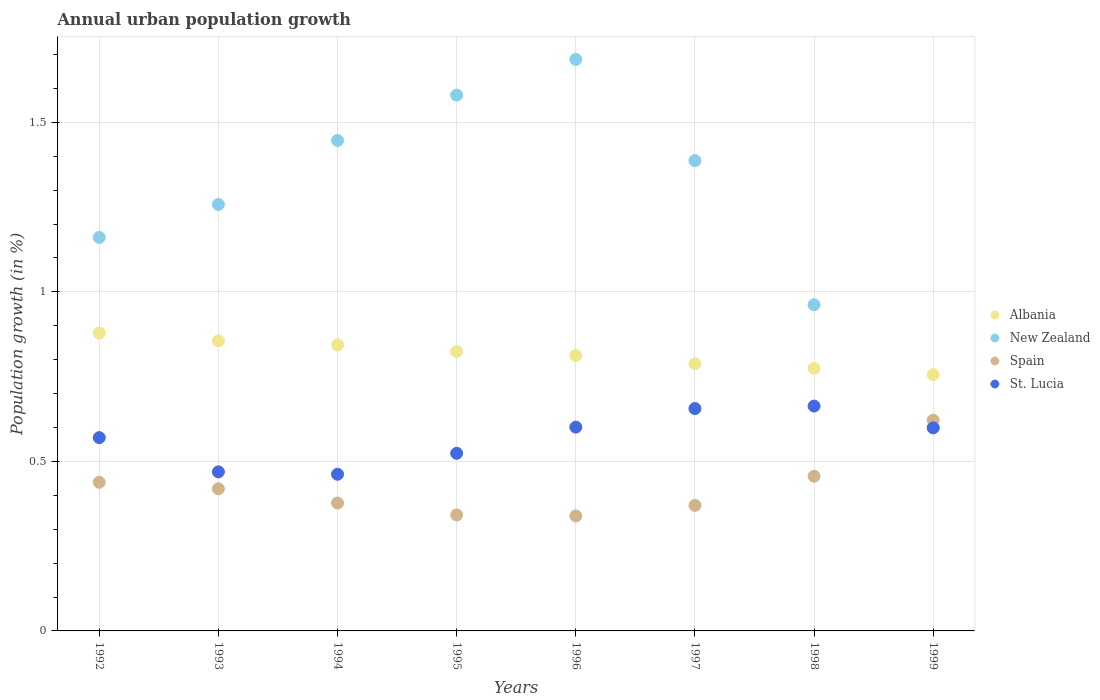How many different coloured dotlines are there?
Your response must be concise. 4. Is the number of dotlines equal to the number of legend labels?
Your response must be concise. Yes. What is the percentage of urban population growth in New Zealand in 1994?
Ensure brevity in your answer.  1.45. Across all years, what is the maximum percentage of urban population growth in St. Lucia?
Your answer should be very brief. 0.66. Across all years, what is the minimum percentage of urban population growth in St. Lucia?
Keep it short and to the point. 0.46. In which year was the percentage of urban population growth in Spain minimum?
Offer a terse response. 1996. What is the total percentage of urban population growth in New Zealand in the graph?
Keep it short and to the point. 10.08. What is the difference between the percentage of urban population growth in St. Lucia in 1993 and that in 1996?
Make the answer very short. -0.13. What is the difference between the percentage of urban population growth in St. Lucia in 1992 and the percentage of urban population growth in New Zealand in 1994?
Your answer should be compact. -0.88. What is the average percentage of urban population growth in New Zealand per year?
Offer a very short reply. 1.26. In the year 1994, what is the difference between the percentage of urban population growth in Spain and percentage of urban population growth in New Zealand?
Provide a succinct answer. -1.07. In how many years, is the percentage of urban population growth in New Zealand greater than 0.2 %?
Make the answer very short. 8. What is the ratio of the percentage of urban population growth in St. Lucia in 1994 to that in 1995?
Offer a terse response. 0.88. Is the percentage of urban population growth in Albania in 1992 less than that in 1999?
Your answer should be very brief. No. Is the difference between the percentage of urban population growth in Spain in 1993 and 1998 greater than the difference between the percentage of urban population growth in New Zealand in 1993 and 1998?
Your response must be concise. No. What is the difference between the highest and the second highest percentage of urban population growth in Spain?
Offer a very short reply. 0.17. What is the difference between the highest and the lowest percentage of urban population growth in Albania?
Ensure brevity in your answer.  0.12. In how many years, is the percentage of urban population growth in Albania greater than the average percentage of urban population growth in Albania taken over all years?
Keep it short and to the point. 4. Is the sum of the percentage of urban population growth in New Zealand in 1997 and 1999 greater than the maximum percentage of urban population growth in Albania across all years?
Make the answer very short. Yes. Is it the case that in every year, the sum of the percentage of urban population growth in St. Lucia and percentage of urban population growth in Spain  is greater than the sum of percentage of urban population growth in Albania and percentage of urban population growth in New Zealand?
Make the answer very short. No. Is it the case that in every year, the sum of the percentage of urban population growth in Albania and percentage of urban population growth in Spain  is greater than the percentage of urban population growth in St. Lucia?
Ensure brevity in your answer.  Yes. Is the percentage of urban population growth in New Zealand strictly greater than the percentage of urban population growth in Spain over the years?
Provide a succinct answer. No. Is the percentage of urban population growth in Albania strictly less than the percentage of urban population growth in Spain over the years?
Give a very brief answer. No. How many years are there in the graph?
Your response must be concise. 8. Are the values on the major ticks of Y-axis written in scientific E-notation?
Provide a succinct answer. No. Does the graph contain grids?
Your answer should be compact. Yes. Where does the legend appear in the graph?
Your response must be concise. Center right. How are the legend labels stacked?
Offer a terse response. Vertical. What is the title of the graph?
Provide a succinct answer. Annual urban population growth. What is the label or title of the X-axis?
Your answer should be compact. Years. What is the label or title of the Y-axis?
Keep it short and to the point. Population growth (in %). What is the Population growth (in %) in Albania in 1992?
Offer a terse response. 0.88. What is the Population growth (in %) of New Zealand in 1992?
Your answer should be very brief. 1.16. What is the Population growth (in %) in Spain in 1992?
Provide a short and direct response. 0.44. What is the Population growth (in %) of St. Lucia in 1992?
Offer a terse response. 0.57. What is the Population growth (in %) of Albania in 1993?
Provide a succinct answer. 0.86. What is the Population growth (in %) in New Zealand in 1993?
Ensure brevity in your answer.  1.26. What is the Population growth (in %) of Spain in 1993?
Ensure brevity in your answer.  0.42. What is the Population growth (in %) of St. Lucia in 1993?
Your response must be concise. 0.47. What is the Population growth (in %) in Albania in 1994?
Provide a succinct answer. 0.84. What is the Population growth (in %) in New Zealand in 1994?
Give a very brief answer. 1.45. What is the Population growth (in %) of Spain in 1994?
Your answer should be compact. 0.38. What is the Population growth (in %) in St. Lucia in 1994?
Give a very brief answer. 0.46. What is the Population growth (in %) of Albania in 1995?
Provide a succinct answer. 0.82. What is the Population growth (in %) of New Zealand in 1995?
Your answer should be very brief. 1.58. What is the Population growth (in %) in Spain in 1995?
Give a very brief answer. 0.34. What is the Population growth (in %) in St. Lucia in 1995?
Your answer should be very brief. 0.52. What is the Population growth (in %) in Albania in 1996?
Give a very brief answer. 0.81. What is the Population growth (in %) of New Zealand in 1996?
Your answer should be compact. 1.69. What is the Population growth (in %) of Spain in 1996?
Offer a very short reply. 0.34. What is the Population growth (in %) in St. Lucia in 1996?
Your response must be concise. 0.6. What is the Population growth (in %) in Albania in 1997?
Your response must be concise. 0.79. What is the Population growth (in %) in New Zealand in 1997?
Provide a succinct answer. 1.39. What is the Population growth (in %) of Spain in 1997?
Offer a very short reply. 0.37. What is the Population growth (in %) of St. Lucia in 1997?
Provide a short and direct response. 0.66. What is the Population growth (in %) of Albania in 1998?
Provide a succinct answer. 0.77. What is the Population growth (in %) of New Zealand in 1998?
Your answer should be compact. 0.96. What is the Population growth (in %) in Spain in 1998?
Keep it short and to the point. 0.46. What is the Population growth (in %) in St. Lucia in 1998?
Your answer should be very brief. 0.66. What is the Population growth (in %) in Albania in 1999?
Keep it short and to the point. 0.76. What is the Population growth (in %) in New Zealand in 1999?
Your answer should be very brief. 0.6. What is the Population growth (in %) in Spain in 1999?
Your answer should be compact. 0.62. What is the Population growth (in %) in St. Lucia in 1999?
Provide a short and direct response. 0.6. Across all years, what is the maximum Population growth (in %) in Albania?
Provide a short and direct response. 0.88. Across all years, what is the maximum Population growth (in %) of New Zealand?
Your answer should be very brief. 1.69. Across all years, what is the maximum Population growth (in %) of Spain?
Provide a short and direct response. 0.62. Across all years, what is the maximum Population growth (in %) in St. Lucia?
Make the answer very short. 0.66. Across all years, what is the minimum Population growth (in %) of Albania?
Give a very brief answer. 0.76. Across all years, what is the minimum Population growth (in %) in New Zealand?
Provide a succinct answer. 0.6. Across all years, what is the minimum Population growth (in %) of Spain?
Make the answer very short. 0.34. Across all years, what is the minimum Population growth (in %) of St. Lucia?
Your answer should be compact. 0.46. What is the total Population growth (in %) of Albania in the graph?
Provide a short and direct response. 6.53. What is the total Population growth (in %) in New Zealand in the graph?
Provide a short and direct response. 10.08. What is the total Population growth (in %) of Spain in the graph?
Offer a terse response. 3.36. What is the total Population growth (in %) in St. Lucia in the graph?
Keep it short and to the point. 4.54. What is the difference between the Population growth (in %) of Albania in 1992 and that in 1993?
Make the answer very short. 0.02. What is the difference between the Population growth (in %) in New Zealand in 1992 and that in 1993?
Provide a short and direct response. -0.1. What is the difference between the Population growth (in %) in Spain in 1992 and that in 1993?
Ensure brevity in your answer.  0.02. What is the difference between the Population growth (in %) of St. Lucia in 1992 and that in 1993?
Give a very brief answer. 0.1. What is the difference between the Population growth (in %) in Albania in 1992 and that in 1994?
Your answer should be compact. 0.03. What is the difference between the Population growth (in %) of New Zealand in 1992 and that in 1994?
Provide a short and direct response. -0.29. What is the difference between the Population growth (in %) in Spain in 1992 and that in 1994?
Your answer should be very brief. 0.06. What is the difference between the Population growth (in %) of St. Lucia in 1992 and that in 1994?
Your response must be concise. 0.11. What is the difference between the Population growth (in %) in Albania in 1992 and that in 1995?
Keep it short and to the point. 0.05. What is the difference between the Population growth (in %) in New Zealand in 1992 and that in 1995?
Offer a very short reply. -0.42. What is the difference between the Population growth (in %) of Spain in 1992 and that in 1995?
Give a very brief answer. 0.1. What is the difference between the Population growth (in %) of St. Lucia in 1992 and that in 1995?
Make the answer very short. 0.05. What is the difference between the Population growth (in %) in Albania in 1992 and that in 1996?
Give a very brief answer. 0.07. What is the difference between the Population growth (in %) of New Zealand in 1992 and that in 1996?
Make the answer very short. -0.53. What is the difference between the Population growth (in %) in Spain in 1992 and that in 1996?
Offer a terse response. 0.1. What is the difference between the Population growth (in %) of St. Lucia in 1992 and that in 1996?
Your answer should be compact. -0.03. What is the difference between the Population growth (in %) of Albania in 1992 and that in 1997?
Your response must be concise. 0.09. What is the difference between the Population growth (in %) in New Zealand in 1992 and that in 1997?
Make the answer very short. -0.23. What is the difference between the Population growth (in %) of Spain in 1992 and that in 1997?
Your answer should be compact. 0.07. What is the difference between the Population growth (in %) of St. Lucia in 1992 and that in 1997?
Provide a succinct answer. -0.09. What is the difference between the Population growth (in %) in Albania in 1992 and that in 1998?
Keep it short and to the point. 0.1. What is the difference between the Population growth (in %) of New Zealand in 1992 and that in 1998?
Make the answer very short. 0.2. What is the difference between the Population growth (in %) of Spain in 1992 and that in 1998?
Ensure brevity in your answer.  -0.02. What is the difference between the Population growth (in %) of St. Lucia in 1992 and that in 1998?
Your answer should be compact. -0.09. What is the difference between the Population growth (in %) in Albania in 1992 and that in 1999?
Give a very brief answer. 0.12. What is the difference between the Population growth (in %) in New Zealand in 1992 and that in 1999?
Your answer should be compact. 0.56. What is the difference between the Population growth (in %) in Spain in 1992 and that in 1999?
Provide a succinct answer. -0.18. What is the difference between the Population growth (in %) of St. Lucia in 1992 and that in 1999?
Provide a succinct answer. -0.03. What is the difference between the Population growth (in %) in Albania in 1993 and that in 1994?
Your answer should be very brief. 0.01. What is the difference between the Population growth (in %) in New Zealand in 1993 and that in 1994?
Offer a terse response. -0.19. What is the difference between the Population growth (in %) in Spain in 1993 and that in 1994?
Your answer should be very brief. 0.04. What is the difference between the Population growth (in %) in St. Lucia in 1993 and that in 1994?
Ensure brevity in your answer.  0.01. What is the difference between the Population growth (in %) of Albania in 1993 and that in 1995?
Give a very brief answer. 0.03. What is the difference between the Population growth (in %) of New Zealand in 1993 and that in 1995?
Your response must be concise. -0.32. What is the difference between the Population growth (in %) of Spain in 1993 and that in 1995?
Your answer should be compact. 0.08. What is the difference between the Population growth (in %) in St. Lucia in 1993 and that in 1995?
Your answer should be compact. -0.05. What is the difference between the Population growth (in %) in Albania in 1993 and that in 1996?
Offer a very short reply. 0.04. What is the difference between the Population growth (in %) in New Zealand in 1993 and that in 1996?
Give a very brief answer. -0.43. What is the difference between the Population growth (in %) of Spain in 1993 and that in 1996?
Keep it short and to the point. 0.08. What is the difference between the Population growth (in %) in St. Lucia in 1993 and that in 1996?
Provide a short and direct response. -0.13. What is the difference between the Population growth (in %) of Albania in 1993 and that in 1997?
Your response must be concise. 0.07. What is the difference between the Population growth (in %) in New Zealand in 1993 and that in 1997?
Provide a short and direct response. -0.13. What is the difference between the Population growth (in %) of Spain in 1993 and that in 1997?
Keep it short and to the point. 0.05. What is the difference between the Population growth (in %) of St. Lucia in 1993 and that in 1997?
Give a very brief answer. -0.19. What is the difference between the Population growth (in %) of Albania in 1993 and that in 1998?
Offer a very short reply. 0.08. What is the difference between the Population growth (in %) of New Zealand in 1993 and that in 1998?
Ensure brevity in your answer.  0.3. What is the difference between the Population growth (in %) of Spain in 1993 and that in 1998?
Make the answer very short. -0.04. What is the difference between the Population growth (in %) in St. Lucia in 1993 and that in 1998?
Your answer should be compact. -0.19. What is the difference between the Population growth (in %) of Albania in 1993 and that in 1999?
Offer a terse response. 0.1. What is the difference between the Population growth (in %) of New Zealand in 1993 and that in 1999?
Make the answer very short. 0.66. What is the difference between the Population growth (in %) in Spain in 1993 and that in 1999?
Keep it short and to the point. -0.2. What is the difference between the Population growth (in %) of St. Lucia in 1993 and that in 1999?
Keep it short and to the point. -0.13. What is the difference between the Population growth (in %) in Albania in 1994 and that in 1995?
Your answer should be compact. 0.02. What is the difference between the Population growth (in %) of New Zealand in 1994 and that in 1995?
Your response must be concise. -0.13. What is the difference between the Population growth (in %) of Spain in 1994 and that in 1995?
Offer a very short reply. 0.04. What is the difference between the Population growth (in %) of St. Lucia in 1994 and that in 1995?
Your answer should be compact. -0.06. What is the difference between the Population growth (in %) in Albania in 1994 and that in 1996?
Offer a very short reply. 0.03. What is the difference between the Population growth (in %) in New Zealand in 1994 and that in 1996?
Offer a very short reply. -0.24. What is the difference between the Population growth (in %) in Spain in 1994 and that in 1996?
Offer a terse response. 0.04. What is the difference between the Population growth (in %) in St. Lucia in 1994 and that in 1996?
Provide a succinct answer. -0.14. What is the difference between the Population growth (in %) in Albania in 1994 and that in 1997?
Provide a short and direct response. 0.06. What is the difference between the Population growth (in %) in New Zealand in 1994 and that in 1997?
Your answer should be very brief. 0.06. What is the difference between the Population growth (in %) of Spain in 1994 and that in 1997?
Make the answer very short. 0.01. What is the difference between the Population growth (in %) of St. Lucia in 1994 and that in 1997?
Keep it short and to the point. -0.19. What is the difference between the Population growth (in %) of Albania in 1994 and that in 1998?
Ensure brevity in your answer.  0.07. What is the difference between the Population growth (in %) of New Zealand in 1994 and that in 1998?
Provide a succinct answer. 0.48. What is the difference between the Population growth (in %) in Spain in 1994 and that in 1998?
Your answer should be compact. -0.08. What is the difference between the Population growth (in %) of St. Lucia in 1994 and that in 1998?
Your answer should be compact. -0.2. What is the difference between the Population growth (in %) in Albania in 1994 and that in 1999?
Ensure brevity in your answer.  0.09. What is the difference between the Population growth (in %) in New Zealand in 1994 and that in 1999?
Offer a terse response. 0.85. What is the difference between the Population growth (in %) of Spain in 1994 and that in 1999?
Keep it short and to the point. -0.24. What is the difference between the Population growth (in %) in St. Lucia in 1994 and that in 1999?
Give a very brief answer. -0.14. What is the difference between the Population growth (in %) of Albania in 1995 and that in 1996?
Ensure brevity in your answer.  0.01. What is the difference between the Population growth (in %) of New Zealand in 1995 and that in 1996?
Make the answer very short. -0.11. What is the difference between the Population growth (in %) in Spain in 1995 and that in 1996?
Keep it short and to the point. 0. What is the difference between the Population growth (in %) of St. Lucia in 1995 and that in 1996?
Make the answer very short. -0.08. What is the difference between the Population growth (in %) in Albania in 1995 and that in 1997?
Your response must be concise. 0.04. What is the difference between the Population growth (in %) in New Zealand in 1995 and that in 1997?
Give a very brief answer. 0.19. What is the difference between the Population growth (in %) in Spain in 1995 and that in 1997?
Your answer should be compact. -0.03. What is the difference between the Population growth (in %) of St. Lucia in 1995 and that in 1997?
Offer a very short reply. -0.13. What is the difference between the Population growth (in %) of Albania in 1995 and that in 1998?
Your response must be concise. 0.05. What is the difference between the Population growth (in %) in New Zealand in 1995 and that in 1998?
Make the answer very short. 0.62. What is the difference between the Population growth (in %) of Spain in 1995 and that in 1998?
Your answer should be compact. -0.11. What is the difference between the Population growth (in %) in St. Lucia in 1995 and that in 1998?
Your response must be concise. -0.14. What is the difference between the Population growth (in %) in Albania in 1995 and that in 1999?
Offer a very short reply. 0.07. What is the difference between the Population growth (in %) of New Zealand in 1995 and that in 1999?
Your response must be concise. 0.98. What is the difference between the Population growth (in %) of Spain in 1995 and that in 1999?
Your response must be concise. -0.28. What is the difference between the Population growth (in %) of St. Lucia in 1995 and that in 1999?
Give a very brief answer. -0.07. What is the difference between the Population growth (in %) in Albania in 1996 and that in 1997?
Provide a succinct answer. 0.02. What is the difference between the Population growth (in %) in New Zealand in 1996 and that in 1997?
Your response must be concise. 0.3. What is the difference between the Population growth (in %) in Spain in 1996 and that in 1997?
Your answer should be very brief. -0.03. What is the difference between the Population growth (in %) in St. Lucia in 1996 and that in 1997?
Make the answer very short. -0.05. What is the difference between the Population growth (in %) of Albania in 1996 and that in 1998?
Provide a short and direct response. 0.04. What is the difference between the Population growth (in %) of New Zealand in 1996 and that in 1998?
Your answer should be very brief. 0.72. What is the difference between the Population growth (in %) of Spain in 1996 and that in 1998?
Provide a short and direct response. -0.12. What is the difference between the Population growth (in %) of St. Lucia in 1996 and that in 1998?
Your answer should be very brief. -0.06. What is the difference between the Population growth (in %) in Albania in 1996 and that in 1999?
Provide a short and direct response. 0.06. What is the difference between the Population growth (in %) of New Zealand in 1996 and that in 1999?
Make the answer very short. 1.09. What is the difference between the Population growth (in %) of Spain in 1996 and that in 1999?
Provide a succinct answer. -0.28. What is the difference between the Population growth (in %) of St. Lucia in 1996 and that in 1999?
Your answer should be very brief. 0. What is the difference between the Population growth (in %) in Albania in 1997 and that in 1998?
Keep it short and to the point. 0.01. What is the difference between the Population growth (in %) in New Zealand in 1997 and that in 1998?
Your answer should be compact. 0.43. What is the difference between the Population growth (in %) in Spain in 1997 and that in 1998?
Your answer should be compact. -0.09. What is the difference between the Population growth (in %) in St. Lucia in 1997 and that in 1998?
Ensure brevity in your answer.  -0.01. What is the difference between the Population growth (in %) of Albania in 1997 and that in 1999?
Offer a terse response. 0.03. What is the difference between the Population growth (in %) of New Zealand in 1997 and that in 1999?
Offer a terse response. 0.79. What is the difference between the Population growth (in %) in Spain in 1997 and that in 1999?
Offer a very short reply. -0.25. What is the difference between the Population growth (in %) in St. Lucia in 1997 and that in 1999?
Your response must be concise. 0.06. What is the difference between the Population growth (in %) of Albania in 1998 and that in 1999?
Provide a short and direct response. 0.02. What is the difference between the Population growth (in %) of New Zealand in 1998 and that in 1999?
Ensure brevity in your answer.  0.36. What is the difference between the Population growth (in %) in Spain in 1998 and that in 1999?
Offer a terse response. -0.17. What is the difference between the Population growth (in %) of St. Lucia in 1998 and that in 1999?
Make the answer very short. 0.06. What is the difference between the Population growth (in %) in Albania in 1992 and the Population growth (in %) in New Zealand in 1993?
Ensure brevity in your answer.  -0.38. What is the difference between the Population growth (in %) of Albania in 1992 and the Population growth (in %) of Spain in 1993?
Your answer should be compact. 0.46. What is the difference between the Population growth (in %) in Albania in 1992 and the Population growth (in %) in St. Lucia in 1993?
Offer a very short reply. 0.41. What is the difference between the Population growth (in %) of New Zealand in 1992 and the Population growth (in %) of Spain in 1993?
Your answer should be compact. 0.74. What is the difference between the Population growth (in %) of New Zealand in 1992 and the Population growth (in %) of St. Lucia in 1993?
Your response must be concise. 0.69. What is the difference between the Population growth (in %) in Spain in 1992 and the Population growth (in %) in St. Lucia in 1993?
Provide a succinct answer. -0.03. What is the difference between the Population growth (in %) of Albania in 1992 and the Population growth (in %) of New Zealand in 1994?
Offer a terse response. -0.57. What is the difference between the Population growth (in %) of Albania in 1992 and the Population growth (in %) of Spain in 1994?
Your response must be concise. 0.5. What is the difference between the Population growth (in %) of Albania in 1992 and the Population growth (in %) of St. Lucia in 1994?
Your response must be concise. 0.42. What is the difference between the Population growth (in %) in New Zealand in 1992 and the Population growth (in %) in Spain in 1994?
Offer a very short reply. 0.78. What is the difference between the Population growth (in %) in New Zealand in 1992 and the Population growth (in %) in St. Lucia in 1994?
Offer a very short reply. 0.7. What is the difference between the Population growth (in %) in Spain in 1992 and the Population growth (in %) in St. Lucia in 1994?
Your answer should be compact. -0.02. What is the difference between the Population growth (in %) of Albania in 1992 and the Population growth (in %) of New Zealand in 1995?
Your answer should be compact. -0.7. What is the difference between the Population growth (in %) of Albania in 1992 and the Population growth (in %) of Spain in 1995?
Ensure brevity in your answer.  0.54. What is the difference between the Population growth (in %) in Albania in 1992 and the Population growth (in %) in St. Lucia in 1995?
Give a very brief answer. 0.35. What is the difference between the Population growth (in %) of New Zealand in 1992 and the Population growth (in %) of Spain in 1995?
Provide a short and direct response. 0.82. What is the difference between the Population growth (in %) in New Zealand in 1992 and the Population growth (in %) in St. Lucia in 1995?
Your answer should be compact. 0.64. What is the difference between the Population growth (in %) of Spain in 1992 and the Population growth (in %) of St. Lucia in 1995?
Keep it short and to the point. -0.09. What is the difference between the Population growth (in %) of Albania in 1992 and the Population growth (in %) of New Zealand in 1996?
Offer a very short reply. -0.81. What is the difference between the Population growth (in %) in Albania in 1992 and the Population growth (in %) in Spain in 1996?
Keep it short and to the point. 0.54. What is the difference between the Population growth (in %) in Albania in 1992 and the Population growth (in %) in St. Lucia in 1996?
Make the answer very short. 0.28. What is the difference between the Population growth (in %) in New Zealand in 1992 and the Population growth (in %) in Spain in 1996?
Your response must be concise. 0.82. What is the difference between the Population growth (in %) in New Zealand in 1992 and the Population growth (in %) in St. Lucia in 1996?
Make the answer very short. 0.56. What is the difference between the Population growth (in %) of Spain in 1992 and the Population growth (in %) of St. Lucia in 1996?
Ensure brevity in your answer.  -0.16. What is the difference between the Population growth (in %) of Albania in 1992 and the Population growth (in %) of New Zealand in 1997?
Your answer should be very brief. -0.51. What is the difference between the Population growth (in %) in Albania in 1992 and the Population growth (in %) in Spain in 1997?
Provide a succinct answer. 0.51. What is the difference between the Population growth (in %) in Albania in 1992 and the Population growth (in %) in St. Lucia in 1997?
Offer a terse response. 0.22. What is the difference between the Population growth (in %) of New Zealand in 1992 and the Population growth (in %) of Spain in 1997?
Provide a succinct answer. 0.79. What is the difference between the Population growth (in %) in New Zealand in 1992 and the Population growth (in %) in St. Lucia in 1997?
Give a very brief answer. 0.5. What is the difference between the Population growth (in %) of Spain in 1992 and the Population growth (in %) of St. Lucia in 1997?
Make the answer very short. -0.22. What is the difference between the Population growth (in %) of Albania in 1992 and the Population growth (in %) of New Zealand in 1998?
Your answer should be compact. -0.08. What is the difference between the Population growth (in %) of Albania in 1992 and the Population growth (in %) of Spain in 1998?
Offer a terse response. 0.42. What is the difference between the Population growth (in %) in Albania in 1992 and the Population growth (in %) in St. Lucia in 1998?
Make the answer very short. 0.22. What is the difference between the Population growth (in %) of New Zealand in 1992 and the Population growth (in %) of Spain in 1998?
Your answer should be compact. 0.7. What is the difference between the Population growth (in %) in New Zealand in 1992 and the Population growth (in %) in St. Lucia in 1998?
Keep it short and to the point. 0.5. What is the difference between the Population growth (in %) in Spain in 1992 and the Population growth (in %) in St. Lucia in 1998?
Your answer should be compact. -0.22. What is the difference between the Population growth (in %) of Albania in 1992 and the Population growth (in %) of New Zealand in 1999?
Ensure brevity in your answer.  0.28. What is the difference between the Population growth (in %) in Albania in 1992 and the Population growth (in %) in Spain in 1999?
Keep it short and to the point. 0.26. What is the difference between the Population growth (in %) of Albania in 1992 and the Population growth (in %) of St. Lucia in 1999?
Ensure brevity in your answer.  0.28. What is the difference between the Population growth (in %) of New Zealand in 1992 and the Population growth (in %) of Spain in 1999?
Ensure brevity in your answer.  0.54. What is the difference between the Population growth (in %) of New Zealand in 1992 and the Population growth (in %) of St. Lucia in 1999?
Make the answer very short. 0.56. What is the difference between the Population growth (in %) in Spain in 1992 and the Population growth (in %) in St. Lucia in 1999?
Offer a very short reply. -0.16. What is the difference between the Population growth (in %) in Albania in 1993 and the Population growth (in %) in New Zealand in 1994?
Offer a terse response. -0.59. What is the difference between the Population growth (in %) in Albania in 1993 and the Population growth (in %) in Spain in 1994?
Your answer should be very brief. 0.48. What is the difference between the Population growth (in %) of Albania in 1993 and the Population growth (in %) of St. Lucia in 1994?
Offer a terse response. 0.39. What is the difference between the Population growth (in %) in New Zealand in 1993 and the Population growth (in %) in Spain in 1994?
Your answer should be compact. 0.88. What is the difference between the Population growth (in %) of New Zealand in 1993 and the Population growth (in %) of St. Lucia in 1994?
Keep it short and to the point. 0.8. What is the difference between the Population growth (in %) of Spain in 1993 and the Population growth (in %) of St. Lucia in 1994?
Ensure brevity in your answer.  -0.04. What is the difference between the Population growth (in %) in Albania in 1993 and the Population growth (in %) in New Zealand in 1995?
Keep it short and to the point. -0.72. What is the difference between the Population growth (in %) of Albania in 1993 and the Population growth (in %) of Spain in 1995?
Keep it short and to the point. 0.51. What is the difference between the Population growth (in %) of Albania in 1993 and the Population growth (in %) of St. Lucia in 1995?
Make the answer very short. 0.33. What is the difference between the Population growth (in %) in New Zealand in 1993 and the Population growth (in %) in Spain in 1995?
Your answer should be very brief. 0.92. What is the difference between the Population growth (in %) in New Zealand in 1993 and the Population growth (in %) in St. Lucia in 1995?
Make the answer very short. 0.73. What is the difference between the Population growth (in %) in Spain in 1993 and the Population growth (in %) in St. Lucia in 1995?
Offer a terse response. -0.1. What is the difference between the Population growth (in %) of Albania in 1993 and the Population growth (in %) of New Zealand in 1996?
Offer a terse response. -0.83. What is the difference between the Population growth (in %) in Albania in 1993 and the Population growth (in %) in Spain in 1996?
Offer a terse response. 0.52. What is the difference between the Population growth (in %) of Albania in 1993 and the Population growth (in %) of St. Lucia in 1996?
Provide a short and direct response. 0.25. What is the difference between the Population growth (in %) of New Zealand in 1993 and the Population growth (in %) of Spain in 1996?
Keep it short and to the point. 0.92. What is the difference between the Population growth (in %) in New Zealand in 1993 and the Population growth (in %) in St. Lucia in 1996?
Offer a very short reply. 0.66. What is the difference between the Population growth (in %) of Spain in 1993 and the Population growth (in %) of St. Lucia in 1996?
Keep it short and to the point. -0.18. What is the difference between the Population growth (in %) in Albania in 1993 and the Population growth (in %) in New Zealand in 1997?
Provide a short and direct response. -0.53. What is the difference between the Population growth (in %) in Albania in 1993 and the Population growth (in %) in Spain in 1997?
Your answer should be very brief. 0.49. What is the difference between the Population growth (in %) of Albania in 1993 and the Population growth (in %) of St. Lucia in 1997?
Ensure brevity in your answer.  0.2. What is the difference between the Population growth (in %) of New Zealand in 1993 and the Population growth (in %) of Spain in 1997?
Your answer should be compact. 0.89. What is the difference between the Population growth (in %) of New Zealand in 1993 and the Population growth (in %) of St. Lucia in 1997?
Make the answer very short. 0.6. What is the difference between the Population growth (in %) in Spain in 1993 and the Population growth (in %) in St. Lucia in 1997?
Your answer should be very brief. -0.24. What is the difference between the Population growth (in %) in Albania in 1993 and the Population growth (in %) in New Zealand in 1998?
Your response must be concise. -0.11. What is the difference between the Population growth (in %) in Albania in 1993 and the Population growth (in %) in Spain in 1998?
Your answer should be compact. 0.4. What is the difference between the Population growth (in %) in Albania in 1993 and the Population growth (in %) in St. Lucia in 1998?
Provide a short and direct response. 0.19. What is the difference between the Population growth (in %) of New Zealand in 1993 and the Population growth (in %) of Spain in 1998?
Make the answer very short. 0.8. What is the difference between the Population growth (in %) in New Zealand in 1993 and the Population growth (in %) in St. Lucia in 1998?
Ensure brevity in your answer.  0.59. What is the difference between the Population growth (in %) of Spain in 1993 and the Population growth (in %) of St. Lucia in 1998?
Your response must be concise. -0.24. What is the difference between the Population growth (in %) in Albania in 1993 and the Population growth (in %) in New Zealand in 1999?
Give a very brief answer. 0.26. What is the difference between the Population growth (in %) of Albania in 1993 and the Population growth (in %) of Spain in 1999?
Make the answer very short. 0.23. What is the difference between the Population growth (in %) of Albania in 1993 and the Population growth (in %) of St. Lucia in 1999?
Ensure brevity in your answer.  0.26. What is the difference between the Population growth (in %) in New Zealand in 1993 and the Population growth (in %) in Spain in 1999?
Offer a very short reply. 0.64. What is the difference between the Population growth (in %) in New Zealand in 1993 and the Population growth (in %) in St. Lucia in 1999?
Offer a very short reply. 0.66. What is the difference between the Population growth (in %) in Spain in 1993 and the Population growth (in %) in St. Lucia in 1999?
Offer a terse response. -0.18. What is the difference between the Population growth (in %) of Albania in 1994 and the Population growth (in %) of New Zealand in 1995?
Provide a succinct answer. -0.74. What is the difference between the Population growth (in %) of Albania in 1994 and the Population growth (in %) of Spain in 1995?
Offer a terse response. 0.5. What is the difference between the Population growth (in %) in Albania in 1994 and the Population growth (in %) in St. Lucia in 1995?
Provide a succinct answer. 0.32. What is the difference between the Population growth (in %) in New Zealand in 1994 and the Population growth (in %) in Spain in 1995?
Provide a succinct answer. 1.1. What is the difference between the Population growth (in %) in New Zealand in 1994 and the Population growth (in %) in St. Lucia in 1995?
Offer a terse response. 0.92. What is the difference between the Population growth (in %) in Spain in 1994 and the Population growth (in %) in St. Lucia in 1995?
Your response must be concise. -0.15. What is the difference between the Population growth (in %) in Albania in 1994 and the Population growth (in %) in New Zealand in 1996?
Keep it short and to the point. -0.84. What is the difference between the Population growth (in %) in Albania in 1994 and the Population growth (in %) in Spain in 1996?
Offer a terse response. 0.5. What is the difference between the Population growth (in %) in Albania in 1994 and the Population growth (in %) in St. Lucia in 1996?
Offer a very short reply. 0.24. What is the difference between the Population growth (in %) in New Zealand in 1994 and the Population growth (in %) in Spain in 1996?
Your response must be concise. 1.11. What is the difference between the Population growth (in %) of New Zealand in 1994 and the Population growth (in %) of St. Lucia in 1996?
Offer a very short reply. 0.85. What is the difference between the Population growth (in %) of Spain in 1994 and the Population growth (in %) of St. Lucia in 1996?
Your answer should be compact. -0.22. What is the difference between the Population growth (in %) in Albania in 1994 and the Population growth (in %) in New Zealand in 1997?
Your response must be concise. -0.54. What is the difference between the Population growth (in %) in Albania in 1994 and the Population growth (in %) in Spain in 1997?
Keep it short and to the point. 0.47. What is the difference between the Population growth (in %) of Albania in 1994 and the Population growth (in %) of St. Lucia in 1997?
Provide a short and direct response. 0.19. What is the difference between the Population growth (in %) of New Zealand in 1994 and the Population growth (in %) of Spain in 1997?
Your response must be concise. 1.08. What is the difference between the Population growth (in %) in New Zealand in 1994 and the Population growth (in %) in St. Lucia in 1997?
Ensure brevity in your answer.  0.79. What is the difference between the Population growth (in %) in Spain in 1994 and the Population growth (in %) in St. Lucia in 1997?
Your answer should be very brief. -0.28. What is the difference between the Population growth (in %) of Albania in 1994 and the Population growth (in %) of New Zealand in 1998?
Provide a short and direct response. -0.12. What is the difference between the Population growth (in %) in Albania in 1994 and the Population growth (in %) in Spain in 1998?
Provide a succinct answer. 0.39. What is the difference between the Population growth (in %) in Albania in 1994 and the Population growth (in %) in St. Lucia in 1998?
Your response must be concise. 0.18. What is the difference between the Population growth (in %) of New Zealand in 1994 and the Population growth (in %) of Spain in 1998?
Offer a very short reply. 0.99. What is the difference between the Population growth (in %) of New Zealand in 1994 and the Population growth (in %) of St. Lucia in 1998?
Your response must be concise. 0.78. What is the difference between the Population growth (in %) of Spain in 1994 and the Population growth (in %) of St. Lucia in 1998?
Your answer should be compact. -0.29. What is the difference between the Population growth (in %) of Albania in 1994 and the Population growth (in %) of New Zealand in 1999?
Make the answer very short. 0.24. What is the difference between the Population growth (in %) of Albania in 1994 and the Population growth (in %) of Spain in 1999?
Provide a short and direct response. 0.22. What is the difference between the Population growth (in %) of Albania in 1994 and the Population growth (in %) of St. Lucia in 1999?
Provide a succinct answer. 0.24. What is the difference between the Population growth (in %) of New Zealand in 1994 and the Population growth (in %) of Spain in 1999?
Provide a short and direct response. 0.83. What is the difference between the Population growth (in %) of New Zealand in 1994 and the Population growth (in %) of St. Lucia in 1999?
Your answer should be compact. 0.85. What is the difference between the Population growth (in %) in Spain in 1994 and the Population growth (in %) in St. Lucia in 1999?
Provide a succinct answer. -0.22. What is the difference between the Population growth (in %) in Albania in 1995 and the Population growth (in %) in New Zealand in 1996?
Offer a terse response. -0.86. What is the difference between the Population growth (in %) of Albania in 1995 and the Population growth (in %) of Spain in 1996?
Your response must be concise. 0.48. What is the difference between the Population growth (in %) of Albania in 1995 and the Population growth (in %) of St. Lucia in 1996?
Ensure brevity in your answer.  0.22. What is the difference between the Population growth (in %) of New Zealand in 1995 and the Population growth (in %) of Spain in 1996?
Offer a terse response. 1.24. What is the difference between the Population growth (in %) in New Zealand in 1995 and the Population growth (in %) in St. Lucia in 1996?
Your answer should be compact. 0.98. What is the difference between the Population growth (in %) of Spain in 1995 and the Population growth (in %) of St. Lucia in 1996?
Offer a very short reply. -0.26. What is the difference between the Population growth (in %) of Albania in 1995 and the Population growth (in %) of New Zealand in 1997?
Your answer should be very brief. -0.56. What is the difference between the Population growth (in %) in Albania in 1995 and the Population growth (in %) in Spain in 1997?
Your answer should be compact. 0.45. What is the difference between the Population growth (in %) in Albania in 1995 and the Population growth (in %) in St. Lucia in 1997?
Give a very brief answer. 0.17. What is the difference between the Population growth (in %) of New Zealand in 1995 and the Population growth (in %) of Spain in 1997?
Your answer should be compact. 1.21. What is the difference between the Population growth (in %) of New Zealand in 1995 and the Population growth (in %) of St. Lucia in 1997?
Offer a terse response. 0.92. What is the difference between the Population growth (in %) in Spain in 1995 and the Population growth (in %) in St. Lucia in 1997?
Offer a terse response. -0.31. What is the difference between the Population growth (in %) in Albania in 1995 and the Population growth (in %) in New Zealand in 1998?
Provide a short and direct response. -0.14. What is the difference between the Population growth (in %) of Albania in 1995 and the Population growth (in %) of Spain in 1998?
Your response must be concise. 0.37. What is the difference between the Population growth (in %) of Albania in 1995 and the Population growth (in %) of St. Lucia in 1998?
Your response must be concise. 0.16. What is the difference between the Population growth (in %) of New Zealand in 1995 and the Population growth (in %) of Spain in 1998?
Your response must be concise. 1.12. What is the difference between the Population growth (in %) in New Zealand in 1995 and the Population growth (in %) in St. Lucia in 1998?
Ensure brevity in your answer.  0.92. What is the difference between the Population growth (in %) of Spain in 1995 and the Population growth (in %) of St. Lucia in 1998?
Provide a short and direct response. -0.32. What is the difference between the Population growth (in %) of Albania in 1995 and the Population growth (in %) of New Zealand in 1999?
Provide a succinct answer. 0.22. What is the difference between the Population growth (in %) in Albania in 1995 and the Population growth (in %) in Spain in 1999?
Provide a succinct answer. 0.2. What is the difference between the Population growth (in %) in Albania in 1995 and the Population growth (in %) in St. Lucia in 1999?
Your answer should be very brief. 0.23. What is the difference between the Population growth (in %) of New Zealand in 1995 and the Population growth (in %) of Spain in 1999?
Make the answer very short. 0.96. What is the difference between the Population growth (in %) in New Zealand in 1995 and the Population growth (in %) in St. Lucia in 1999?
Your answer should be compact. 0.98. What is the difference between the Population growth (in %) of Spain in 1995 and the Population growth (in %) of St. Lucia in 1999?
Offer a terse response. -0.26. What is the difference between the Population growth (in %) of Albania in 1996 and the Population growth (in %) of New Zealand in 1997?
Offer a terse response. -0.57. What is the difference between the Population growth (in %) of Albania in 1996 and the Population growth (in %) of Spain in 1997?
Ensure brevity in your answer.  0.44. What is the difference between the Population growth (in %) in Albania in 1996 and the Population growth (in %) in St. Lucia in 1997?
Offer a very short reply. 0.16. What is the difference between the Population growth (in %) of New Zealand in 1996 and the Population growth (in %) of Spain in 1997?
Your answer should be very brief. 1.32. What is the difference between the Population growth (in %) in New Zealand in 1996 and the Population growth (in %) in St. Lucia in 1997?
Offer a very short reply. 1.03. What is the difference between the Population growth (in %) in Spain in 1996 and the Population growth (in %) in St. Lucia in 1997?
Provide a short and direct response. -0.32. What is the difference between the Population growth (in %) of Albania in 1996 and the Population growth (in %) of New Zealand in 1998?
Make the answer very short. -0.15. What is the difference between the Population growth (in %) of Albania in 1996 and the Population growth (in %) of Spain in 1998?
Provide a succinct answer. 0.36. What is the difference between the Population growth (in %) in Albania in 1996 and the Population growth (in %) in St. Lucia in 1998?
Offer a terse response. 0.15. What is the difference between the Population growth (in %) of New Zealand in 1996 and the Population growth (in %) of Spain in 1998?
Keep it short and to the point. 1.23. What is the difference between the Population growth (in %) of New Zealand in 1996 and the Population growth (in %) of St. Lucia in 1998?
Provide a succinct answer. 1.02. What is the difference between the Population growth (in %) of Spain in 1996 and the Population growth (in %) of St. Lucia in 1998?
Provide a succinct answer. -0.32. What is the difference between the Population growth (in %) in Albania in 1996 and the Population growth (in %) in New Zealand in 1999?
Ensure brevity in your answer.  0.21. What is the difference between the Population growth (in %) of Albania in 1996 and the Population growth (in %) of Spain in 1999?
Give a very brief answer. 0.19. What is the difference between the Population growth (in %) in Albania in 1996 and the Population growth (in %) in St. Lucia in 1999?
Make the answer very short. 0.21. What is the difference between the Population growth (in %) in New Zealand in 1996 and the Population growth (in %) in Spain in 1999?
Offer a terse response. 1.06. What is the difference between the Population growth (in %) in New Zealand in 1996 and the Population growth (in %) in St. Lucia in 1999?
Keep it short and to the point. 1.09. What is the difference between the Population growth (in %) in Spain in 1996 and the Population growth (in %) in St. Lucia in 1999?
Provide a short and direct response. -0.26. What is the difference between the Population growth (in %) of Albania in 1997 and the Population growth (in %) of New Zealand in 1998?
Offer a terse response. -0.17. What is the difference between the Population growth (in %) of Albania in 1997 and the Population growth (in %) of Spain in 1998?
Your answer should be very brief. 0.33. What is the difference between the Population growth (in %) of New Zealand in 1997 and the Population growth (in %) of Spain in 1998?
Give a very brief answer. 0.93. What is the difference between the Population growth (in %) in New Zealand in 1997 and the Population growth (in %) in St. Lucia in 1998?
Your answer should be very brief. 0.72. What is the difference between the Population growth (in %) of Spain in 1997 and the Population growth (in %) of St. Lucia in 1998?
Provide a short and direct response. -0.29. What is the difference between the Population growth (in %) of Albania in 1997 and the Population growth (in %) of New Zealand in 1999?
Your response must be concise. 0.19. What is the difference between the Population growth (in %) in Albania in 1997 and the Population growth (in %) in St. Lucia in 1999?
Your response must be concise. 0.19. What is the difference between the Population growth (in %) of New Zealand in 1997 and the Population growth (in %) of Spain in 1999?
Keep it short and to the point. 0.77. What is the difference between the Population growth (in %) of New Zealand in 1997 and the Population growth (in %) of St. Lucia in 1999?
Ensure brevity in your answer.  0.79. What is the difference between the Population growth (in %) of Spain in 1997 and the Population growth (in %) of St. Lucia in 1999?
Your answer should be compact. -0.23. What is the difference between the Population growth (in %) in Albania in 1998 and the Population growth (in %) in New Zealand in 1999?
Provide a short and direct response. 0.17. What is the difference between the Population growth (in %) of Albania in 1998 and the Population growth (in %) of Spain in 1999?
Offer a terse response. 0.15. What is the difference between the Population growth (in %) of Albania in 1998 and the Population growth (in %) of St. Lucia in 1999?
Provide a short and direct response. 0.18. What is the difference between the Population growth (in %) in New Zealand in 1998 and the Population growth (in %) in Spain in 1999?
Your response must be concise. 0.34. What is the difference between the Population growth (in %) of New Zealand in 1998 and the Population growth (in %) of St. Lucia in 1999?
Your answer should be very brief. 0.36. What is the difference between the Population growth (in %) in Spain in 1998 and the Population growth (in %) in St. Lucia in 1999?
Offer a very short reply. -0.14. What is the average Population growth (in %) of Albania per year?
Your response must be concise. 0.82. What is the average Population growth (in %) in New Zealand per year?
Make the answer very short. 1.26. What is the average Population growth (in %) in Spain per year?
Your response must be concise. 0.42. What is the average Population growth (in %) in St. Lucia per year?
Provide a succinct answer. 0.57. In the year 1992, what is the difference between the Population growth (in %) of Albania and Population growth (in %) of New Zealand?
Give a very brief answer. -0.28. In the year 1992, what is the difference between the Population growth (in %) of Albania and Population growth (in %) of Spain?
Your answer should be compact. 0.44. In the year 1992, what is the difference between the Population growth (in %) in Albania and Population growth (in %) in St. Lucia?
Provide a succinct answer. 0.31. In the year 1992, what is the difference between the Population growth (in %) of New Zealand and Population growth (in %) of Spain?
Your response must be concise. 0.72. In the year 1992, what is the difference between the Population growth (in %) in New Zealand and Population growth (in %) in St. Lucia?
Give a very brief answer. 0.59. In the year 1992, what is the difference between the Population growth (in %) of Spain and Population growth (in %) of St. Lucia?
Ensure brevity in your answer.  -0.13. In the year 1993, what is the difference between the Population growth (in %) in Albania and Population growth (in %) in New Zealand?
Your response must be concise. -0.4. In the year 1993, what is the difference between the Population growth (in %) of Albania and Population growth (in %) of Spain?
Ensure brevity in your answer.  0.44. In the year 1993, what is the difference between the Population growth (in %) of Albania and Population growth (in %) of St. Lucia?
Offer a terse response. 0.39. In the year 1993, what is the difference between the Population growth (in %) in New Zealand and Population growth (in %) in Spain?
Provide a succinct answer. 0.84. In the year 1993, what is the difference between the Population growth (in %) in New Zealand and Population growth (in %) in St. Lucia?
Offer a terse response. 0.79. In the year 1993, what is the difference between the Population growth (in %) in Spain and Population growth (in %) in St. Lucia?
Provide a succinct answer. -0.05. In the year 1994, what is the difference between the Population growth (in %) in Albania and Population growth (in %) in New Zealand?
Offer a terse response. -0.6. In the year 1994, what is the difference between the Population growth (in %) in Albania and Population growth (in %) in Spain?
Offer a terse response. 0.47. In the year 1994, what is the difference between the Population growth (in %) of Albania and Population growth (in %) of St. Lucia?
Offer a terse response. 0.38. In the year 1994, what is the difference between the Population growth (in %) in New Zealand and Population growth (in %) in Spain?
Your response must be concise. 1.07. In the year 1994, what is the difference between the Population growth (in %) in New Zealand and Population growth (in %) in St. Lucia?
Provide a succinct answer. 0.98. In the year 1994, what is the difference between the Population growth (in %) of Spain and Population growth (in %) of St. Lucia?
Offer a terse response. -0.08. In the year 1995, what is the difference between the Population growth (in %) of Albania and Population growth (in %) of New Zealand?
Provide a short and direct response. -0.76. In the year 1995, what is the difference between the Population growth (in %) in Albania and Population growth (in %) in Spain?
Keep it short and to the point. 0.48. In the year 1995, what is the difference between the Population growth (in %) in Albania and Population growth (in %) in St. Lucia?
Give a very brief answer. 0.3. In the year 1995, what is the difference between the Population growth (in %) in New Zealand and Population growth (in %) in Spain?
Provide a short and direct response. 1.24. In the year 1995, what is the difference between the Population growth (in %) of New Zealand and Population growth (in %) of St. Lucia?
Provide a short and direct response. 1.06. In the year 1995, what is the difference between the Population growth (in %) in Spain and Population growth (in %) in St. Lucia?
Your answer should be very brief. -0.18. In the year 1996, what is the difference between the Population growth (in %) of Albania and Population growth (in %) of New Zealand?
Provide a short and direct response. -0.87. In the year 1996, what is the difference between the Population growth (in %) of Albania and Population growth (in %) of Spain?
Your response must be concise. 0.47. In the year 1996, what is the difference between the Population growth (in %) of Albania and Population growth (in %) of St. Lucia?
Provide a short and direct response. 0.21. In the year 1996, what is the difference between the Population growth (in %) of New Zealand and Population growth (in %) of Spain?
Offer a very short reply. 1.35. In the year 1996, what is the difference between the Population growth (in %) of New Zealand and Population growth (in %) of St. Lucia?
Your answer should be compact. 1.08. In the year 1996, what is the difference between the Population growth (in %) of Spain and Population growth (in %) of St. Lucia?
Ensure brevity in your answer.  -0.26. In the year 1997, what is the difference between the Population growth (in %) of Albania and Population growth (in %) of New Zealand?
Ensure brevity in your answer.  -0.6. In the year 1997, what is the difference between the Population growth (in %) of Albania and Population growth (in %) of Spain?
Your answer should be compact. 0.42. In the year 1997, what is the difference between the Population growth (in %) of Albania and Population growth (in %) of St. Lucia?
Give a very brief answer. 0.13. In the year 1997, what is the difference between the Population growth (in %) in New Zealand and Population growth (in %) in St. Lucia?
Your answer should be compact. 0.73. In the year 1997, what is the difference between the Population growth (in %) of Spain and Population growth (in %) of St. Lucia?
Your answer should be very brief. -0.29. In the year 1998, what is the difference between the Population growth (in %) of Albania and Population growth (in %) of New Zealand?
Your answer should be very brief. -0.19. In the year 1998, what is the difference between the Population growth (in %) in Albania and Population growth (in %) in Spain?
Offer a very short reply. 0.32. In the year 1998, what is the difference between the Population growth (in %) in Albania and Population growth (in %) in St. Lucia?
Offer a terse response. 0.11. In the year 1998, what is the difference between the Population growth (in %) of New Zealand and Population growth (in %) of Spain?
Your answer should be very brief. 0.51. In the year 1998, what is the difference between the Population growth (in %) in New Zealand and Population growth (in %) in St. Lucia?
Your response must be concise. 0.3. In the year 1998, what is the difference between the Population growth (in %) in Spain and Population growth (in %) in St. Lucia?
Keep it short and to the point. -0.21. In the year 1999, what is the difference between the Population growth (in %) of Albania and Population growth (in %) of New Zealand?
Keep it short and to the point. 0.16. In the year 1999, what is the difference between the Population growth (in %) of Albania and Population growth (in %) of Spain?
Offer a terse response. 0.13. In the year 1999, what is the difference between the Population growth (in %) of Albania and Population growth (in %) of St. Lucia?
Ensure brevity in your answer.  0.16. In the year 1999, what is the difference between the Population growth (in %) in New Zealand and Population growth (in %) in Spain?
Keep it short and to the point. -0.02. In the year 1999, what is the difference between the Population growth (in %) of New Zealand and Population growth (in %) of St. Lucia?
Provide a short and direct response. 0. In the year 1999, what is the difference between the Population growth (in %) in Spain and Population growth (in %) in St. Lucia?
Offer a very short reply. 0.02. What is the ratio of the Population growth (in %) of Albania in 1992 to that in 1993?
Your response must be concise. 1.03. What is the ratio of the Population growth (in %) in New Zealand in 1992 to that in 1993?
Your answer should be very brief. 0.92. What is the ratio of the Population growth (in %) in Spain in 1992 to that in 1993?
Provide a succinct answer. 1.05. What is the ratio of the Population growth (in %) in St. Lucia in 1992 to that in 1993?
Your response must be concise. 1.22. What is the ratio of the Population growth (in %) in Albania in 1992 to that in 1994?
Offer a very short reply. 1.04. What is the ratio of the Population growth (in %) of New Zealand in 1992 to that in 1994?
Provide a succinct answer. 0.8. What is the ratio of the Population growth (in %) of Spain in 1992 to that in 1994?
Provide a short and direct response. 1.16. What is the ratio of the Population growth (in %) of St. Lucia in 1992 to that in 1994?
Offer a very short reply. 1.23. What is the ratio of the Population growth (in %) of Albania in 1992 to that in 1995?
Offer a very short reply. 1.07. What is the ratio of the Population growth (in %) in New Zealand in 1992 to that in 1995?
Provide a succinct answer. 0.73. What is the ratio of the Population growth (in %) in Spain in 1992 to that in 1995?
Provide a short and direct response. 1.28. What is the ratio of the Population growth (in %) of St. Lucia in 1992 to that in 1995?
Provide a short and direct response. 1.09. What is the ratio of the Population growth (in %) of Albania in 1992 to that in 1996?
Your answer should be compact. 1.08. What is the ratio of the Population growth (in %) in New Zealand in 1992 to that in 1996?
Provide a succinct answer. 0.69. What is the ratio of the Population growth (in %) of Spain in 1992 to that in 1996?
Keep it short and to the point. 1.29. What is the ratio of the Population growth (in %) of St. Lucia in 1992 to that in 1996?
Give a very brief answer. 0.95. What is the ratio of the Population growth (in %) in Albania in 1992 to that in 1997?
Give a very brief answer. 1.11. What is the ratio of the Population growth (in %) in New Zealand in 1992 to that in 1997?
Provide a short and direct response. 0.84. What is the ratio of the Population growth (in %) in Spain in 1992 to that in 1997?
Ensure brevity in your answer.  1.18. What is the ratio of the Population growth (in %) in St. Lucia in 1992 to that in 1997?
Offer a terse response. 0.87. What is the ratio of the Population growth (in %) in Albania in 1992 to that in 1998?
Your response must be concise. 1.13. What is the ratio of the Population growth (in %) of New Zealand in 1992 to that in 1998?
Provide a short and direct response. 1.21. What is the ratio of the Population growth (in %) in St. Lucia in 1992 to that in 1998?
Provide a short and direct response. 0.86. What is the ratio of the Population growth (in %) of Albania in 1992 to that in 1999?
Make the answer very short. 1.16. What is the ratio of the Population growth (in %) of New Zealand in 1992 to that in 1999?
Provide a succinct answer. 1.93. What is the ratio of the Population growth (in %) in Spain in 1992 to that in 1999?
Make the answer very short. 0.71. What is the ratio of the Population growth (in %) of Albania in 1993 to that in 1994?
Provide a succinct answer. 1.01. What is the ratio of the Population growth (in %) of New Zealand in 1993 to that in 1994?
Offer a terse response. 0.87. What is the ratio of the Population growth (in %) in Spain in 1993 to that in 1994?
Your answer should be very brief. 1.11. What is the ratio of the Population growth (in %) in Albania in 1993 to that in 1995?
Give a very brief answer. 1.04. What is the ratio of the Population growth (in %) of New Zealand in 1993 to that in 1995?
Make the answer very short. 0.8. What is the ratio of the Population growth (in %) in Spain in 1993 to that in 1995?
Your answer should be very brief. 1.23. What is the ratio of the Population growth (in %) in St. Lucia in 1993 to that in 1995?
Give a very brief answer. 0.9. What is the ratio of the Population growth (in %) in Albania in 1993 to that in 1996?
Keep it short and to the point. 1.05. What is the ratio of the Population growth (in %) of New Zealand in 1993 to that in 1996?
Make the answer very short. 0.75. What is the ratio of the Population growth (in %) of Spain in 1993 to that in 1996?
Give a very brief answer. 1.24. What is the ratio of the Population growth (in %) of St. Lucia in 1993 to that in 1996?
Provide a short and direct response. 0.78. What is the ratio of the Population growth (in %) in Albania in 1993 to that in 1997?
Your answer should be compact. 1.09. What is the ratio of the Population growth (in %) in New Zealand in 1993 to that in 1997?
Keep it short and to the point. 0.91. What is the ratio of the Population growth (in %) of Spain in 1993 to that in 1997?
Provide a short and direct response. 1.13. What is the ratio of the Population growth (in %) in St. Lucia in 1993 to that in 1997?
Provide a short and direct response. 0.72. What is the ratio of the Population growth (in %) in Albania in 1993 to that in 1998?
Make the answer very short. 1.1. What is the ratio of the Population growth (in %) of New Zealand in 1993 to that in 1998?
Ensure brevity in your answer.  1.31. What is the ratio of the Population growth (in %) of Spain in 1993 to that in 1998?
Offer a terse response. 0.92. What is the ratio of the Population growth (in %) of St. Lucia in 1993 to that in 1998?
Your answer should be compact. 0.71. What is the ratio of the Population growth (in %) in Albania in 1993 to that in 1999?
Offer a very short reply. 1.13. What is the ratio of the Population growth (in %) in New Zealand in 1993 to that in 1999?
Give a very brief answer. 2.1. What is the ratio of the Population growth (in %) of Spain in 1993 to that in 1999?
Keep it short and to the point. 0.67. What is the ratio of the Population growth (in %) in St. Lucia in 1993 to that in 1999?
Your response must be concise. 0.78. What is the ratio of the Population growth (in %) of Albania in 1994 to that in 1995?
Offer a terse response. 1.02. What is the ratio of the Population growth (in %) in New Zealand in 1994 to that in 1995?
Offer a very short reply. 0.92. What is the ratio of the Population growth (in %) in Spain in 1994 to that in 1995?
Offer a very short reply. 1.1. What is the ratio of the Population growth (in %) in St. Lucia in 1994 to that in 1995?
Your answer should be very brief. 0.88. What is the ratio of the Population growth (in %) of Albania in 1994 to that in 1996?
Offer a very short reply. 1.04. What is the ratio of the Population growth (in %) in New Zealand in 1994 to that in 1996?
Offer a very short reply. 0.86. What is the ratio of the Population growth (in %) in Spain in 1994 to that in 1996?
Provide a succinct answer. 1.11. What is the ratio of the Population growth (in %) of St. Lucia in 1994 to that in 1996?
Ensure brevity in your answer.  0.77. What is the ratio of the Population growth (in %) in Albania in 1994 to that in 1997?
Make the answer very short. 1.07. What is the ratio of the Population growth (in %) in New Zealand in 1994 to that in 1997?
Provide a short and direct response. 1.04. What is the ratio of the Population growth (in %) in Spain in 1994 to that in 1997?
Make the answer very short. 1.02. What is the ratio of the Population growth (in %) in St. Lucia in 1994 to that in 1997?
Offer a terse response. 0.7. What is the ratio of the Population growth (in %) in Albania in 1994 to that in 1998?
Your answer should be compact. 1.09. What is the ratio of the Population growth (in %) in New Zealand in 1994 to that in 1998?
Your answer should be very brief. 1.5. What is the ratio of the Population growth (in %) of Spain in 1994 to that in 1998?
Your answer should be very brief. 0.83. What is the ratio of the Population growth (in %) in St. Lucia in 1994 to that in 1998?
Your answer should be very brief. 0.7. What is the ratio of the Population growth (in %) of Albania in 1994 to that in 1999?
Give a very brief answer. 1.12. What is the ratio of the Population growth (in %) in New Zealand in 1994 to that in 1999?
Your answer should be compact. 2.41. What is the ratio of the Population growth (in %) of Spain in 1994 to that in 1999?
Provide a short and direct response. 0.61. What is the ratio of the Population growth (in %) in St. Lucia in 1994 to that in 1999?
Your answer should be compact. 0.77. What is the ratio of the Population growth (in %) in Albania in 1995 to that in 1996?
Your answer should be very brief. 1.01. What is the ratio of the Population growth (in %) in New Zealand in 1995 to that in 1996?
Offer a very short reply. 0.94. What is the ratio of the Population growth (in %) of Spain in 1995 to that in 1996?
Provide a short and direct response. 1.01. What is the ratio of the Population growth (in %) of St. Lucia in 1995 to that in 1996?
Keep it short and to the point. 0.87. What is the ratio of the Population growth (in %) of Albania in 1995 to that in 1997?
Provide a succinct answer. 1.05. What is the ratio of the Population growth (in %) in New Zealand in 1995 to that in 1997?
Your answer should be very brief. 1.14. What is the ratio of the Population growth (in %) of Spain in 1995 to that in 1997?
Make the answer very short. 0.92. What is the ratio of the Population growth (in %) in St. Lucia in 1995 to that in 1997?
Your answer should be very brief. 0.8. What is the ratio of the Population growth (in %) of Albania in 1995 to that in 1998?
Provide a succinct answer. 1.06. What is the ratio of the Population growth (in %) in New Zealand in 1995 to that in 1998?
Your response must be concise. 1.64. What is the ratio of the Population growth (in %) in Spain in 1995 to that in 1998?
Give a very brief answer. 0.75. What is the ratio of the Population growth (in %) in St. Lucia in 1995 to that in 1998?
Your response must be concise. 0.79. What is the ratio of the Population growth (in %) of Albania in 1995 to that in 1999?
Ensure brevity in your answer.  1.09. What is the ratio of the Population growth (in %) in New Zealand in 1995 to that in 1999?
Provide a succinct answer. 2.63. What is the ratio of the Population growth (in %) in Spain in 1995 to that in 1999?
Offer a very short reply. 0.55. What is the ratio of the Population growth (in %) in St. Lucia in 1995 to that in 1999?
Your answer should be compact. 0.87. What is the ratio of the Population growth (in %) in Albania in 1996 to that in 1997?
Give a very brief answer. 1.03. What is the ratio of the Population growth (in %) in New Zealand in 1996 to that in 1997?
Give a very brief answer. 1.22. What is the ratio of the Population growth (in %) in Spain in 1996 to that in 1997?
Your response must be concise. 0.92. What is the ratio of the Population growth (in %) in St. Lucia in 1996 to that in 1997?
Provide a succinct answer. 0.92. What is the ratio of the Population growth (in %) of Albania in 1996 to that in 1998?
Your answer should be very brief. 1.05. What is the ratio of the Population growth (in %) of New Zealand in 1996 to that in 1998?
Ensure brevity in your answer.  1.75. What is the ratio of the Population growth (in %) of Spain in 1996 to that in 1998?
Your answer should be compact. 0.74. What is the ratio of the Population growth (in %) of St. Lucia in 1996 to that in 1998?
Your answer should be compact. 0.91. What is the ratio of the Population growth (in %) of Albania in 1996 to that in 1999?
Make the answer very short. 1.07. What is the ratio of the Population growth (in %) in New Zealand in 1996 to that in 1999?
Offer a very short reply. 2.81. What is the ratio of the Population growth (in %) of Spain in 1996 to that in 1999?
Keep it short and to the point. 0.55. What is the ratio of the Population growth (in %) of Albania in 1997 to that in 1998?
Give a very brief answer. 1.02. What is the ratio of the Population growth (in %) in New Zealand in 1997 to that in 1998?
Your answer should be very brief. 1.44. What is the ratio of the Population growth (in %) of Spain in 1997 to that in 1998?
Make the answer very short. 0.81. What is the ratio of the Population growth (in %) of St. Lucia in 1997 to that in 1998?
Offer a terse response. 0.99. What is the ratio of the Population growth (in %) in Albania in 1997 to that in 1999?
Offer a terse response. 1.04. What is the ratio of the Population growth (in %) in New Zealand in 1997 to that in 1999?
Make the answer very short. 2.31. What is the ratio of the Population growth (in %) of Spain in 1997 to that in 1999?
Provide a short and direct response. 0.6. What is the ratio of the Population growth (in %) of St. Lucia in 1997 to that in 1999?
Provide a short and direct response. 1.1. What is the ratio of the Population growth (in %) in Albania in 1998 to that in 1999?
Your response must be concise. 1.02. What is the ratio of the Population growth (in %) of New Zealand in 1998 to that in 1999?
Provide a short and direct response. 1.6. What is the ratio of the Population growth (in %) in Spain in 1998 to that in 1999?
Your response must be concise. 0.73. What is the ratio of the Population growth (in %) in St. Lucia in 1998 to that in 1999?
Your answer should be very brief. 1.11. What is the difference between the highest and the second highest Population growth (in %) in Albania?
Provide a succinct answer. 0.02. What is the difference between the highest and the second highest Population growth (in %) of New Zealand?
Give a very brief answer. 0.11. What is the difference between the highest and the second highest Population growth (in %) of Spain?
Your answer should be compact. 0.17. What is the difference between the highest and the second highest Population growth (in %) in St. Lucia?
Your response must be concise. 0.01. What is the difference between the highest and the lowest Population growth (in %) of Albania?
Your answer should be very brief. 0.12. What is the difference between the highest and the lowest Population growth (in %) in New Zealand?
Provide a succinct answer. 1.09. What is the difference between the highest and the lowest Population growth (in %) in Spain?
Provide a succinct answer. 0.28. What is the difference between the highest and the lowest Population growth (in %) in St. Lucia?
Offer a very short reply. 0.2. 